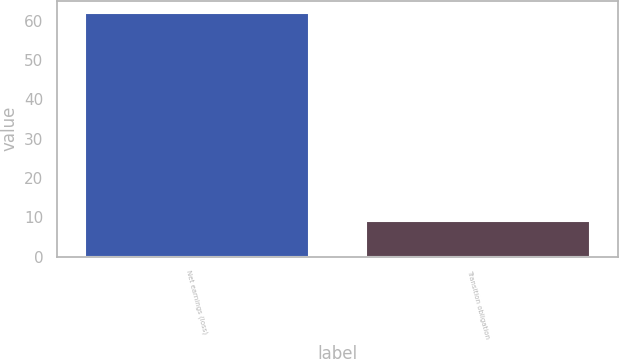<chart> <loc_0><loc_0><loc_500><loc_500><bar_chart><fcel>Net earnings (loss)<fcel>Transition obligation<nl><fcel>62<fcel>9<nl></chart> 